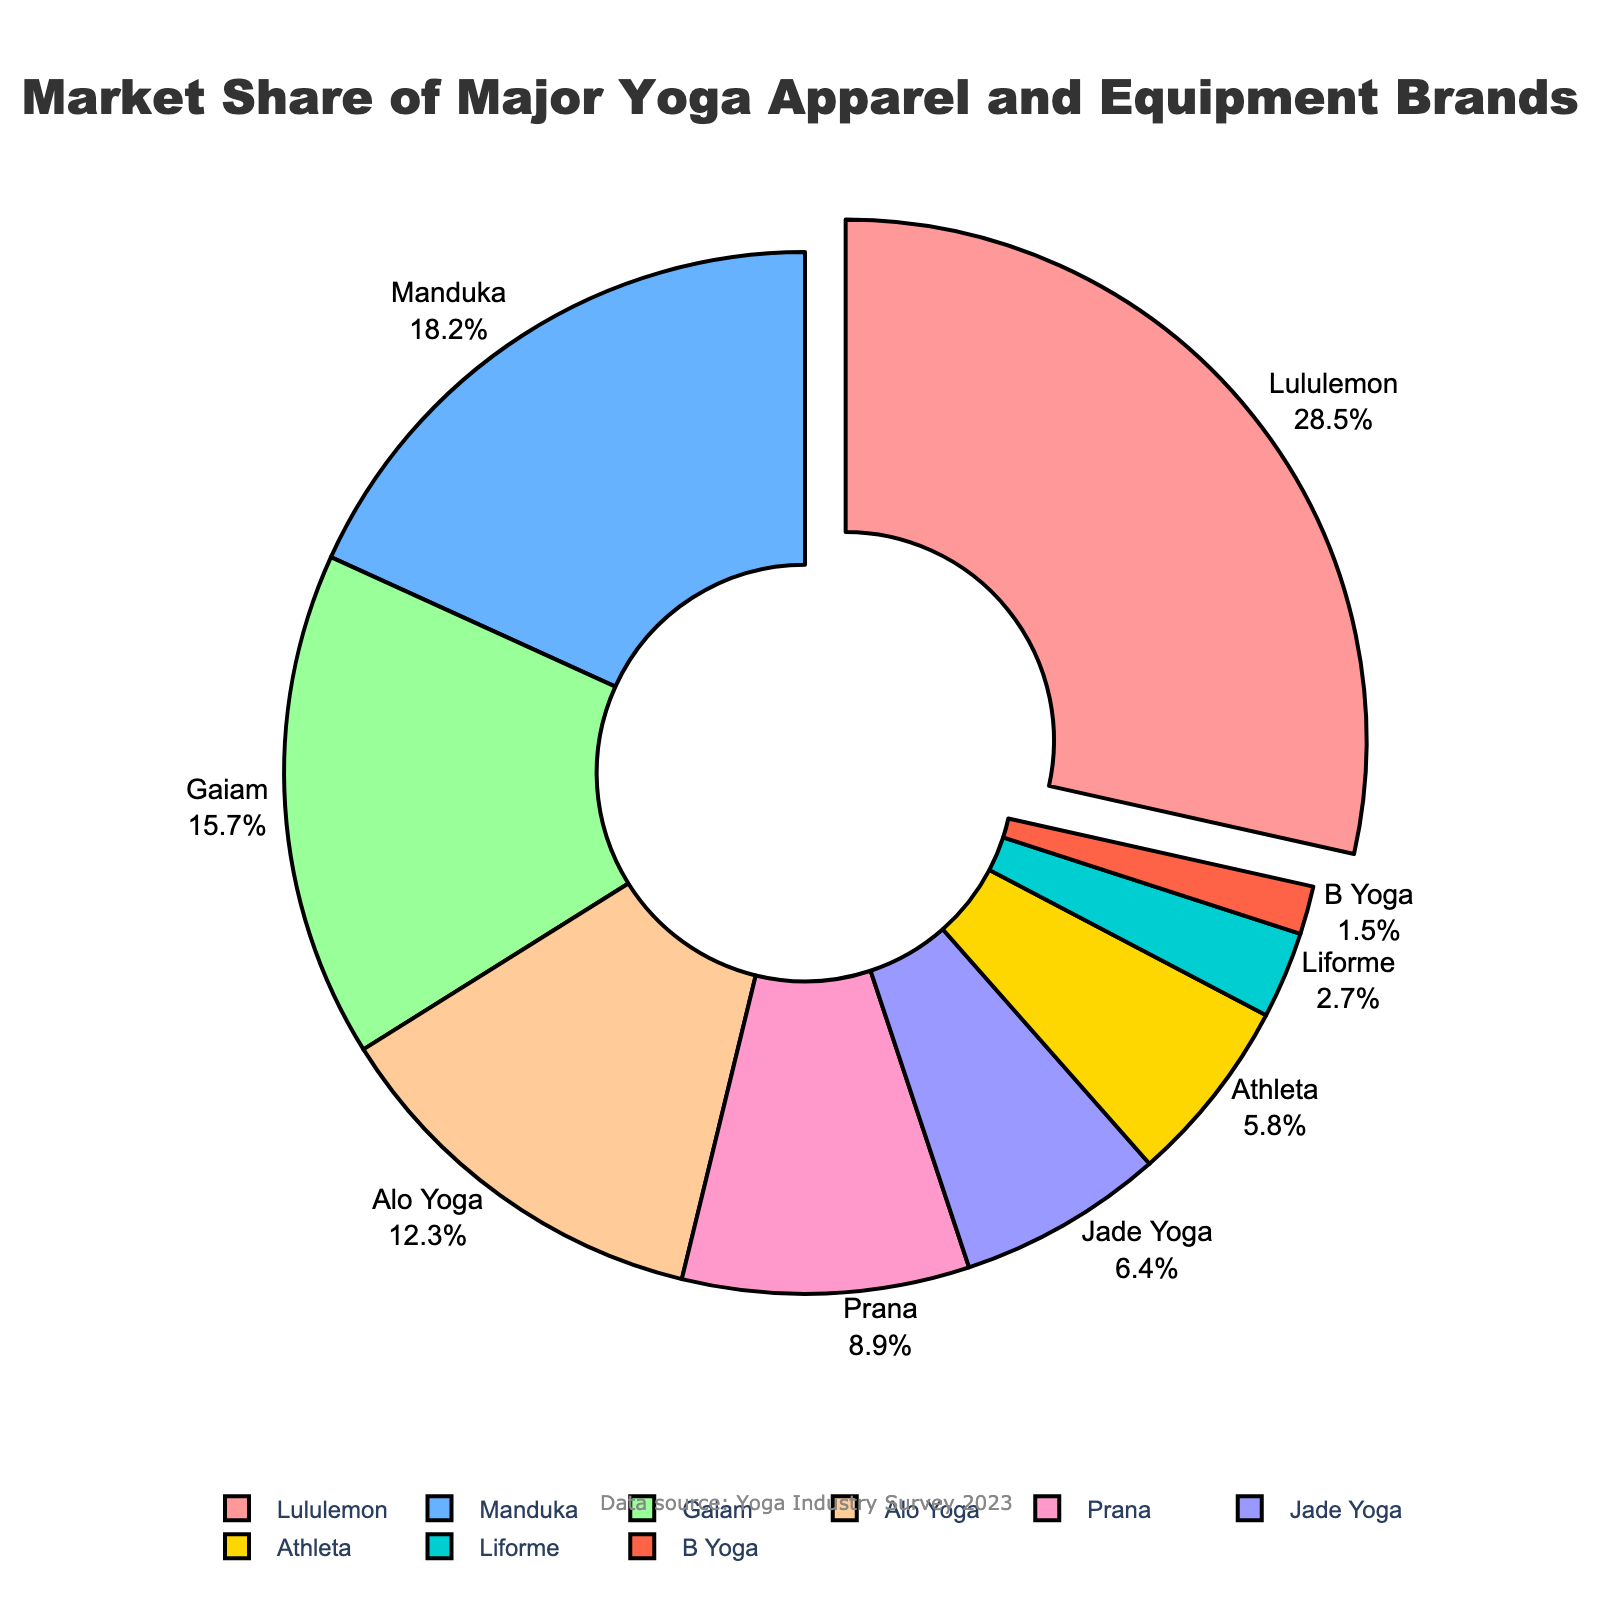What brand holds the largest market share? The largest segment is labeled "Lululemon" with 28.5% market share.
Answer: Lululemon Which two brands combined have the highest market share after Lululemon? The next two largest segments are Manduka (18.2%) and Gaiam (15.7%). Adding them gives 18.2 + 15.7 = 33.9%.
Answer: Manduka and Gaiam How much more market share does Lululemon have compared to Alo Yoga? Lululemon's share is 28.5%. Alo Yoga's share is 12.3%. The difference is 28.5 - 12.3 = 16.2%.
Answer: 16.2% Which brand has the smallest market share, and what is it? The smallest segment is labeled "B Yoga" with 1.5% market share.
Answer: B Yoga, 1.5% How many brands have a market share greater than 10%? Lululemon (28.5%), Manduka (18.2%), Gaiam (15.7%), and Alo Yoga (12.3%) each have a share greater than 10%. In total, there are 4 brands.
Answer: 4 What is the total market share of brands with less than 5% market share? Athleta (5.8%), Liforme (2.7%), and B Yoga (1.5%). The relevant shares are Liforme and B Yoga. Adding them gives 2.7 + 1.5 = 4.2%.
Answer: 4.2% Among the brands with less than 10% market share, which brand has the highest market share? Among the relevant brands, Prana has the highest share with 8.9%.
Answer: Prana What percentage of the market is held by the top three brands combined? Lululemon (28.5%), Manduka (18.2%), and Gaiam (15.7%). Adding them gives 28.5 + 18.2 + 15.7 = 62.4%.
Answer: 62.4% What is the color of the segment for Manduka? The segment for Manduka is the second largest, hence it's colored in blue.
Answer: Blue If you exclude Lululemon, which brand's market share is closest to averaging the remaining brands' shares? Excluding Lululemon's 28.5%, the remaining total market share is 71.5%. There are 8 remaining brands, so the average is 71.5 / 8 = 8.94%. The closest to this value is Prana with 8.9%.
Answer: Prana 